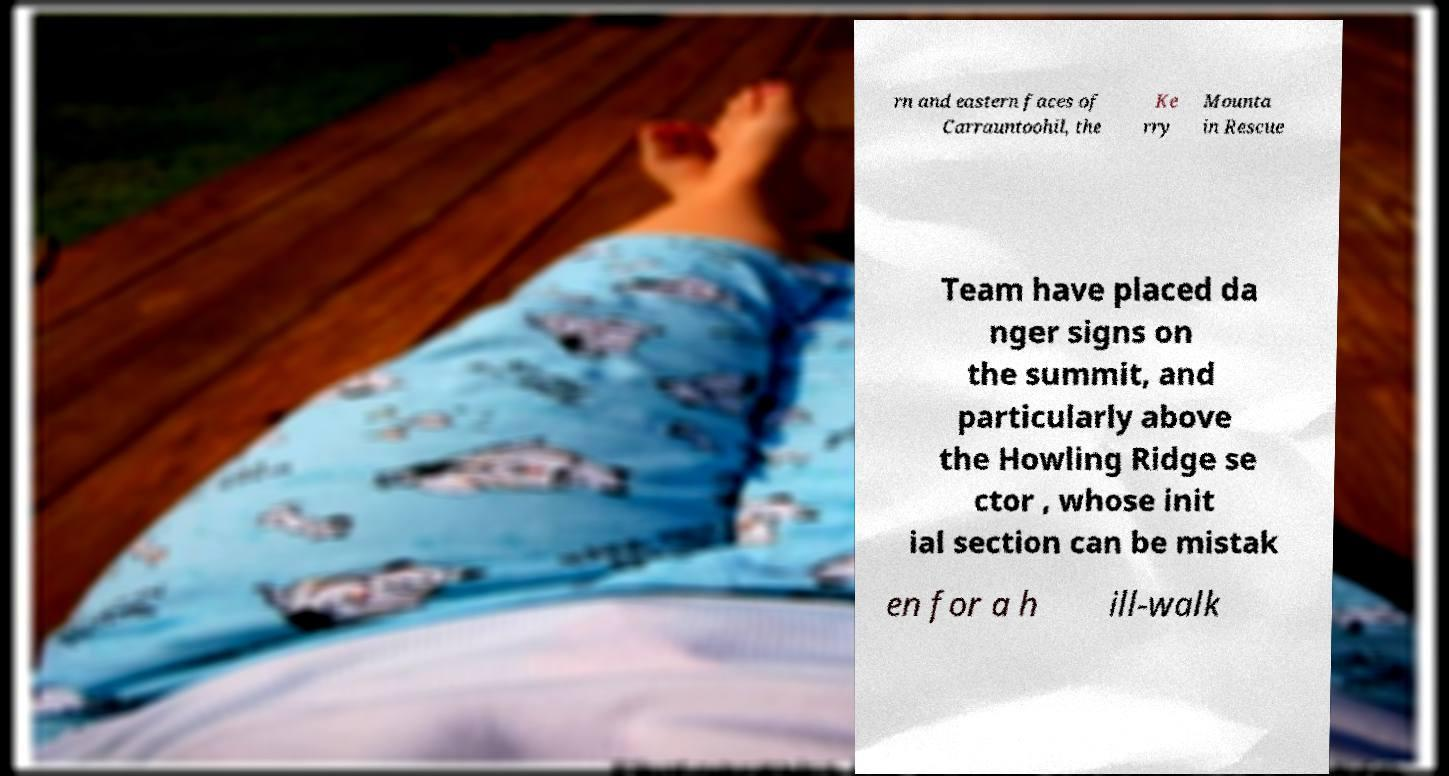There's text embedded in this image that I need extracted. Can you transcribe it verbatim? rn and eastern faces of Carrauntoohil, the Ke rry Mounta in Rescue Team have placed da nger signs on the summit, and particularly above the Howling Ridge se ctor , whose init ial section can be mistak en for a h ill-walk 